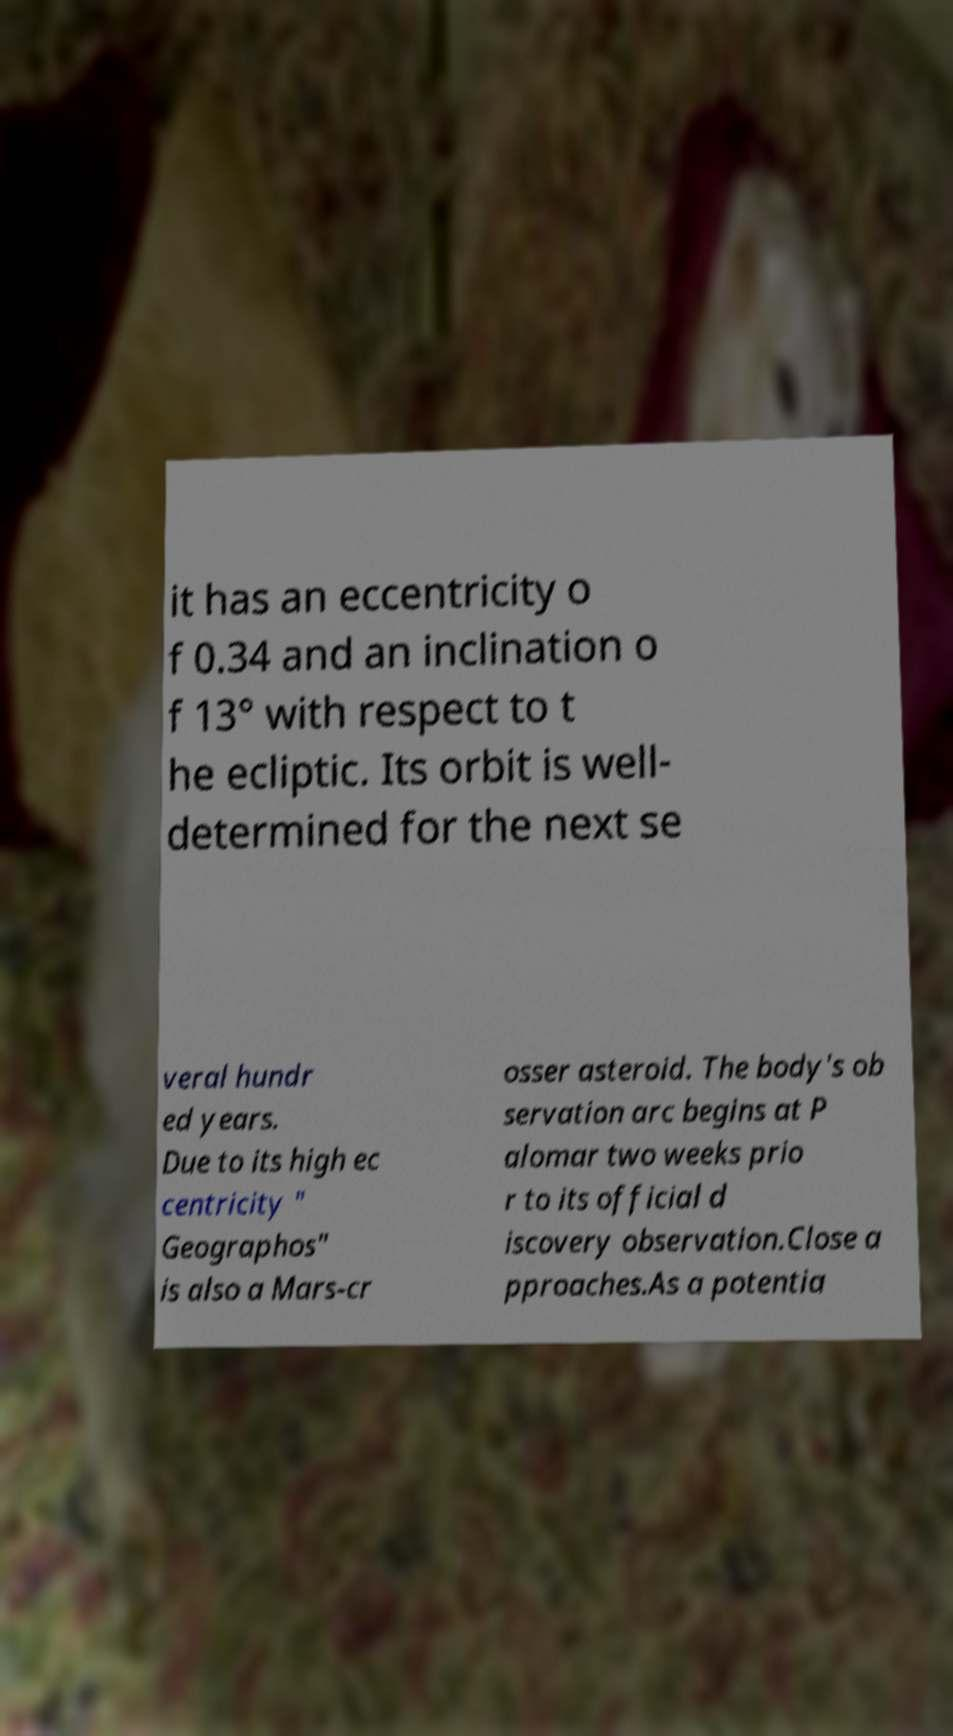Could you assist in decoding the text presented in this image and type it out clearly? it has an eccentricity o f 0.34 and an inclination o f 13° with respect to t he ecliptic. Its orbit is well- determined for the next se veral hundr ed years. Due to its high ec centricity " Geographos" is also a Mars-cr osser asteroid. The body's ob servation arc begins at P alomar two weeks prio r to its official d iscovery observation.Close a pproaches.As a potentia 